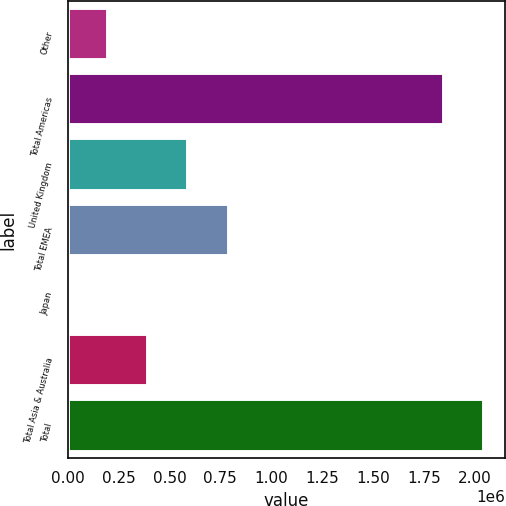Convert chart. <chart><loc_0><loc_0><loc_500><loc_500><bar_chart><fcel>Other<fcel>Total Americas<fcel>United Kingdom<fcel>Total EMEA<fcel>Japan<fcel>Total Asia & Australia<fcel>Total<nl><fcel>198078<fcel>1.84929e+06<fcel>593371<fcel>791017<fcel>432<fcel>395724<fcel>2.04694e+06<nl></chart> 